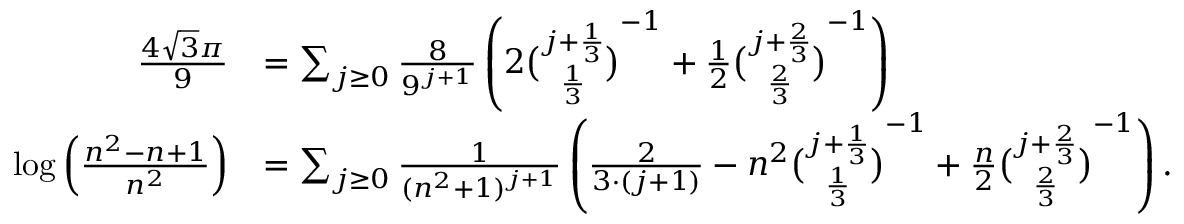<formula> <loc_0><loc_0><loc_500><loc_500>{ \begin{array} { r l } { { \frac { 4 { \sqrt { 3 } } \pi } { 9 } } } & { = \sum _ { j \geq 0 } { \frac { 8 } { 9 ^ { j + 1 } } } \left ( 2 { \binom { j + { \frac { 1 } { 3 } } } { \frac { 1 } { 3 } } } ^ { - 1 } + { \frac { 1 } { 2 } } { \binom { j + { \frac { 2 } { 3 } } } { \frac { 2 } { 3 } } } ^ { - 1 } \right ) } \\ { \log \left ( { \frac { n ^ { 2 } - n + 1 } { n ^ { 2 } } } \right ) } & { = \sum _ { j \geq 0 } { \frac { 1 } { ( n ^ { 2 } + 1 ) ^ { j + 1 } } } \left ( { \frac { 2 } { 3 \cdot ( j + 1 ) } } - n ^ { 2 } { \binom { j + { \frac { 1 } { 3 } } } { \frac { 1 } { 3 } } } ^ { - 1 } + { \frac { n } { 2 } } { \binom { j + { \frac { 2 } { 3 } } } { \frac { 2 } { 3 } } } ^ { - 1 } \right ) . } \end{array} }</formula> 